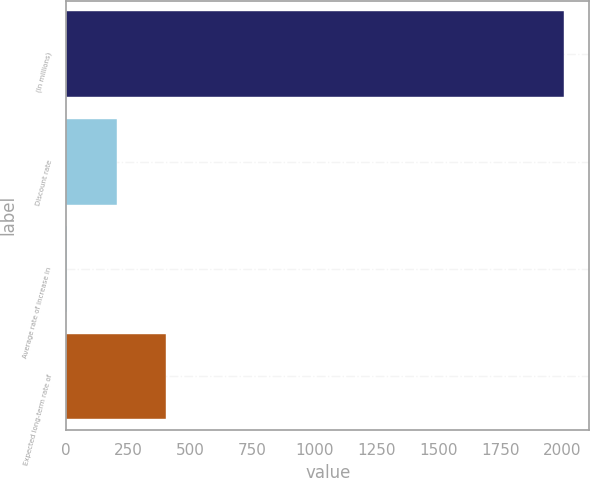Convert chart. <chart><loc_0><loc_0><loc_500><loc_500><bar_chart><fcel>(In millions)<fcel>Discount rate<fcel>Average rate of increase in<fcel>Expected long-term rate of<nl><fcel>2009<fcel>203.86<fcel>3.29<fcel>404.43<nl></chart> 